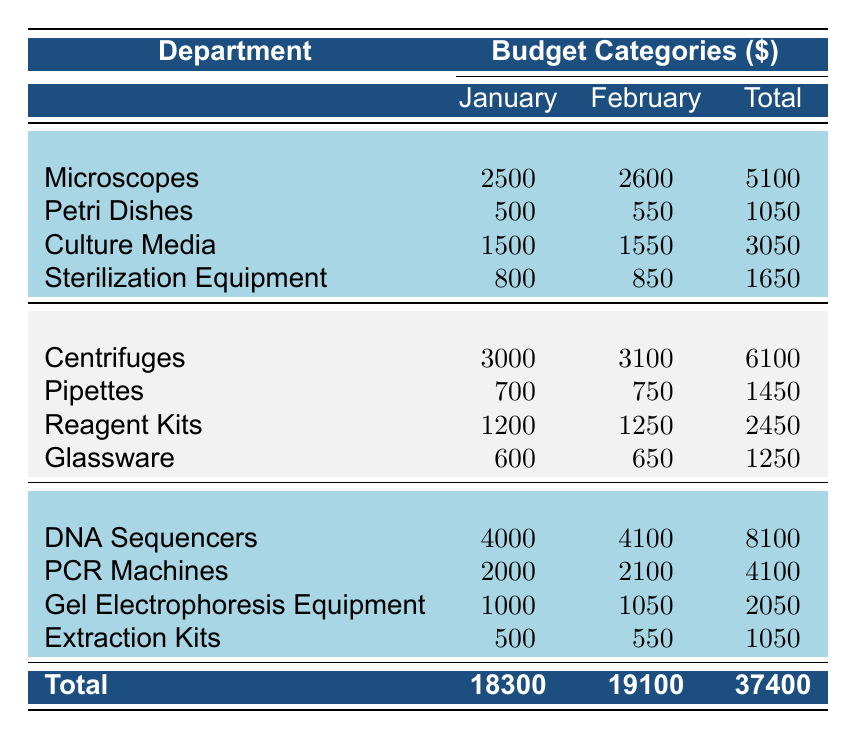What is the total budget allocation for the Microbiology department in January? Referring to the table, the amounts for Microbiology in January are: Microscopes 2500, Petri Dishes 500, Culture Media 1500, Sterilization Equipment 800. Adding these together gives 2500 + 500 + 1500 + 800 = 5100.
Answer: 5100 How much was allocated for PCR Machines in February? The table shows that for Genetics in February, the amount for PCR Machines is 2100.
Answer: 2100 Which department had the highest budget allocation for DNA Sequencers? In the table, the amounts for DNA Sequencers are listed under Genetics: 4000 in January and 4100 in February. Since it is the only department listed for this category, it has the highest allocation, which is 4100.
Answer: 4100 What is the total budget allocated to the Biochemistry department across both months? The table lists the amounts for Biochemistry in January as: Centrifuges 3000, Pipettes 700, Reagent Kits 1200, Glassware 600, totaling 3000 + 700 + 1200 + 600 = 5100. For February, the amounts are 3100 + 750 + 1250 + 650 = 6100. The sum of both months is 5100 + 6100 = 11200.
Answer: 11200 Is the amount allocated for Sterilization Equipment in February greater than the amount allocated for Glassware in January? The February allocation for Sterilization Equipment (850) is compared to January's allocation for Glassware (600). Since 850 is greater than 600, the answer is yes.
Answer: Yes What is the average monthly budget for Culture Media across January and February? The amounts allocated for Culture Media are 1500 in January and 1550 in February. Adding these yields 1500 + 1550 = 3050. Dividing this total by 2 (the number of months) gives 3050/2 = 1525.
Answer: 1525 How much less was spent on Petri Dishes in January compared to February? The allocation for Petri Dishes in January is 500 and in February is 550. To find the difference, subtract January's amount from February's: 550 - 500 = 50.
Answer: 50 What is the total budget allocation for all departments in January? The total budget for January is calculated by summing all categories from each department: Microbiology (5100) + Biochemistry (6100) + Genetics (8100) = 18300.
Answer: 18300 Which department spent the least on Extraction Kits in February compared to their January allocation? In the table, the amount for Extraction Kits in January (500) is compared to February (550) for Genetics. Since 500 is less than 550, Genetics is the department that spent less.
Answer: Genetics 